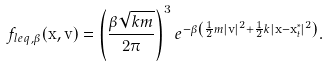Convert formula to latex. <formula><loc_0><loc_0><loc_500><loc_500>f _ { l e q , \beta } ( \mathbf x , \mathbf v ) = \left ( \frac { \beta \sqrt { k m } } { 2 \pi } \right ) ^ { 3 } e ^ { - \beta \left ( \frac { 1 } { 2 } m | \mathbf v | ^ { 2 } + \frac { 1 } { 2 } k | \mathbf x - \mathbf x _ { t } ^ { * } | ^ { 2 } \right ) } .</formula> 